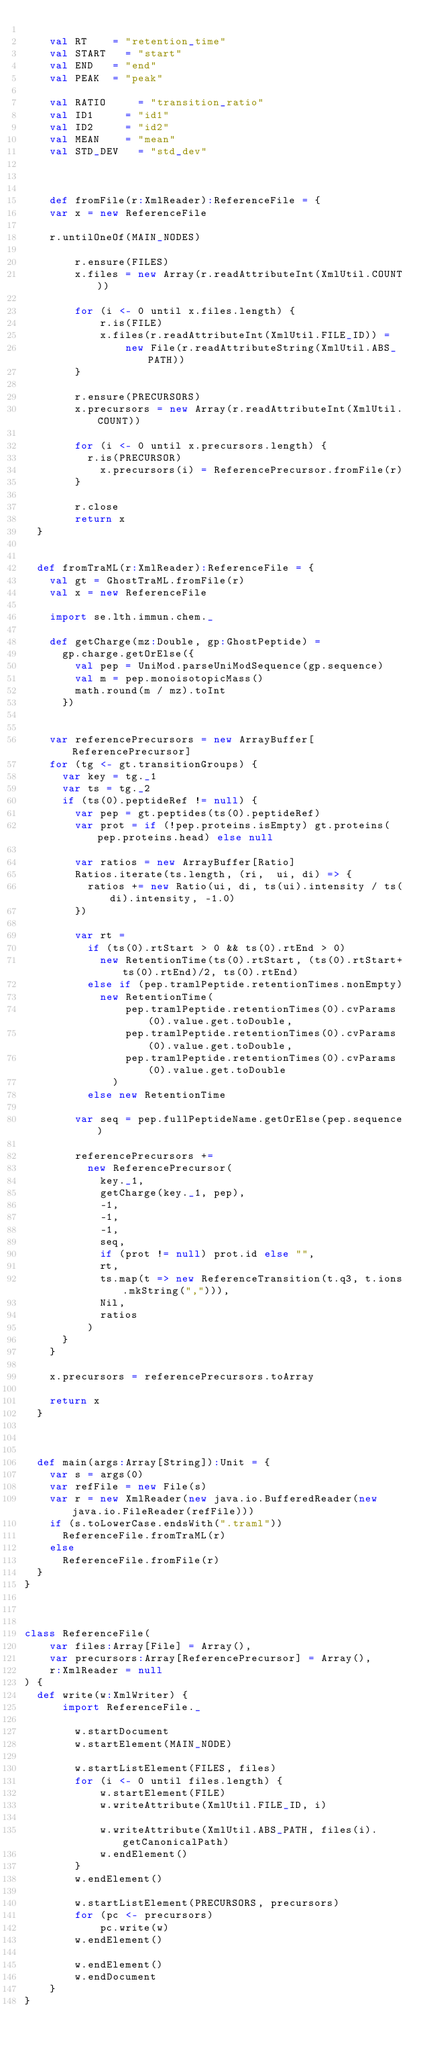Convert code to text. <code><loc_0><loc_0><loc_500><loc_500><_Scala_>    	
    val RT 		= "retention_time"
    val START 	= "start"
    val END 	= "end"
    val PEAK 	= "peak"
    	
    val RATIO 		= "transition_ratio"
    val ID1 		= "id1"
    val ID2 		= "id2"
    val MEAN 		= "mean"
    val STD_DEV 	= "std_dev"
    	
    	
    	
    def fromFile(r:XmlReader):ReferenceFile = {
		var x = new ReferenceFile
		
		r.untilOneOf(MAIN_NODES)

        r.ensure(FILES) 
        x.files = new Array(r.readAttributeInt(XmlUtil.COUNT))

        for (i <- 0 until x.files.length) {
            r.is(FILE)
            x.files(r.readAttributeInt(XmlUtil.FILE_ID)) =
                new File(r.readAttributeString(XmlUtil.ABS_PATH))
        }
        
        r.ensure(PRECURSORS)
        x.precursors = new Array(r.readAttributeInt(XmlUtil.COUNT))

        for (i <- 0 until x.precursors.length) {
        	r.is(PRECURSOR)
            x.precursors(i) = ReferencePrecursor.fromFile(r)
        }
        
        r.close
        return x
	}
	
	
	def fromTraML(r:XmlReader):ReferenceFile = {
		val gt = GhostTraML.fromFile(r)
		val x = new ReferenceFile
		
		import se.lth.immun.chem._
		
		def getCharge(mz:Double, gp:GhostPeptide) = 
			gp.charge.getOrElse({
				val pep = UniMod.parseUniModSequence(gp.sequence)
				val m = pep.monoisotopicMass()
				math.round(m / mz).toInt
			})
		
		
		var referencePrecursors = new ArrayBuffer[ReferencePrecursor]
		for (tg <- gt.transitionGroups) {
			var key = tg._1
			var ts = tg._2
			if (ts(0).peptideRef != null) {
				var pep = gt.peptides(ts(0).peptideRef)
				var prot = if (!pep.proteins.isEmpty) gt.proteins(pep.proteins.head) else null
				
				var ratios = new ArrayBuffer[Ratio]
				Ratios.iterate(ts.length, (ri,  ui, di) => {
					ratios += new Ratio(ui, di, ts(ui).intensity / ts(di).intensity, -1.0)
				})
				
				var rt = 
					if (ts(0).rtStart > 0 && ts(0).rtEnd > 0)
						new RetentionTime(ts(0).rtStart, (ts(0).rtStart+ts(0).rtEnd)/2, ts(0).rtEnd)
					else if (pep.tramlPeptide.retentionTimes.nonEmpty)
						new RetentionTime(
								pep.tramlPeptide.retentionTimes(0).cvParams(0).value.get.toDouble,
								pep.tramlPeptide.retentionTimes(0).cvParams(0).value.get.toDouble,
								pep.tramlPeptide.retentionTimes(0).cvParams(0).value.get.toDouble
							)
					else new RetentionTime
				
				var seq = pep.fullPeptideName.getOrElse(pep.sequence)
					
				referencePrecursors += 
					new ReferencePrecursor(
						key._1,
						getCharge(key._1, pep),
						-1,
						-1,
						-1,
						seq,
						if (prot != null) prot.id else "",
						rt,
						ts.map(t => new ReferenceTransition(t.q3, t.ions.mkString(","))),
						Nil,
						ratios
					)
			}
		}
		
		x.precursors = referencePrecursors.toArray
		
		return x
	}
	
	
	
	def main(args:Array[String]):Unit = {
		var s = args(0)
		var refFile = new File(s)
		var r = new XmlReader(new java.io.BufferedReader(new java.io.FileReader(refFile)))
		if (s.toLowerCase.endsWith(".traml"))
			ReferenceFile.fromTraML(r)
		else 
			ReferenceFile.fromFile(r)
	}
}



class ReferenceFile(
		var files:Array[File] = Array(),
		var precursors:Array[ReferencePrecursor] = Array(),
		r:XmlReader = null
) {
	def write(w:XmlWriter) {
    	import ReferenceFile._
    	
        w.startDocument
        w.startElement(MAIN_NODE)

        w.startListElement(FILES, files)
        for (i <- 0 until files.length) {
            w.startElement(FILE)
            w.writeAttribute(XmlUtil.FILE_ID, i)

            w.writeAttribute(XmlUtil.ABS_PATH, files(i).getCanonicalPath)
            w.endElement()
        }
        w.endElement()

        w.startListElement(PRECURSORS, precursors)
        for (pc <- precursors)
            pc.write(w)
        w.endElement()
            
        w.endElement()
        w.endDocument
    }
}
</code> 